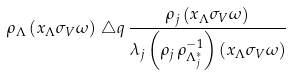Convert formula to latex. <formula><loc_0><loc_0><loc_500><loc_500>\rho _ { \Lambda } \left ( x _ { \Lambda } \sigma _ { V } \omega \right ) \, \triangle q \, \frac { \rho _ { j } \left ( x _ { \Lambda } \sigma _ { V } \omega \right ) } { \lambda _ { j } \left ( \rho _ { j } \, \rho _ { \Lambda ^ { * } _ { j } } ^ { - 1 } \right ) \left ( x _ { \Lambda } \sigma _ { V } \omega \right ) }</formula> 